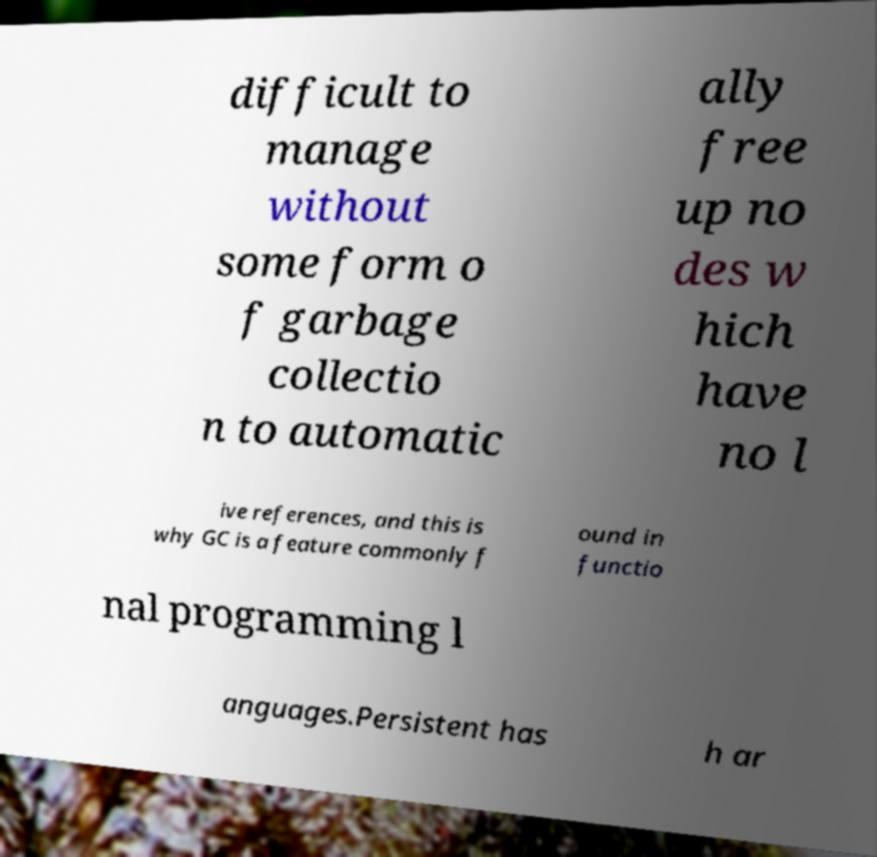Can you accurately transcribe the text from the provided image for me? difficult to manage without some form o f garbage collectio n to automatic ally free up no des w hich have no l ive references, and this is why GC is a feature commonly f ound in functio nal programming l anguages.Persistent has h ar 